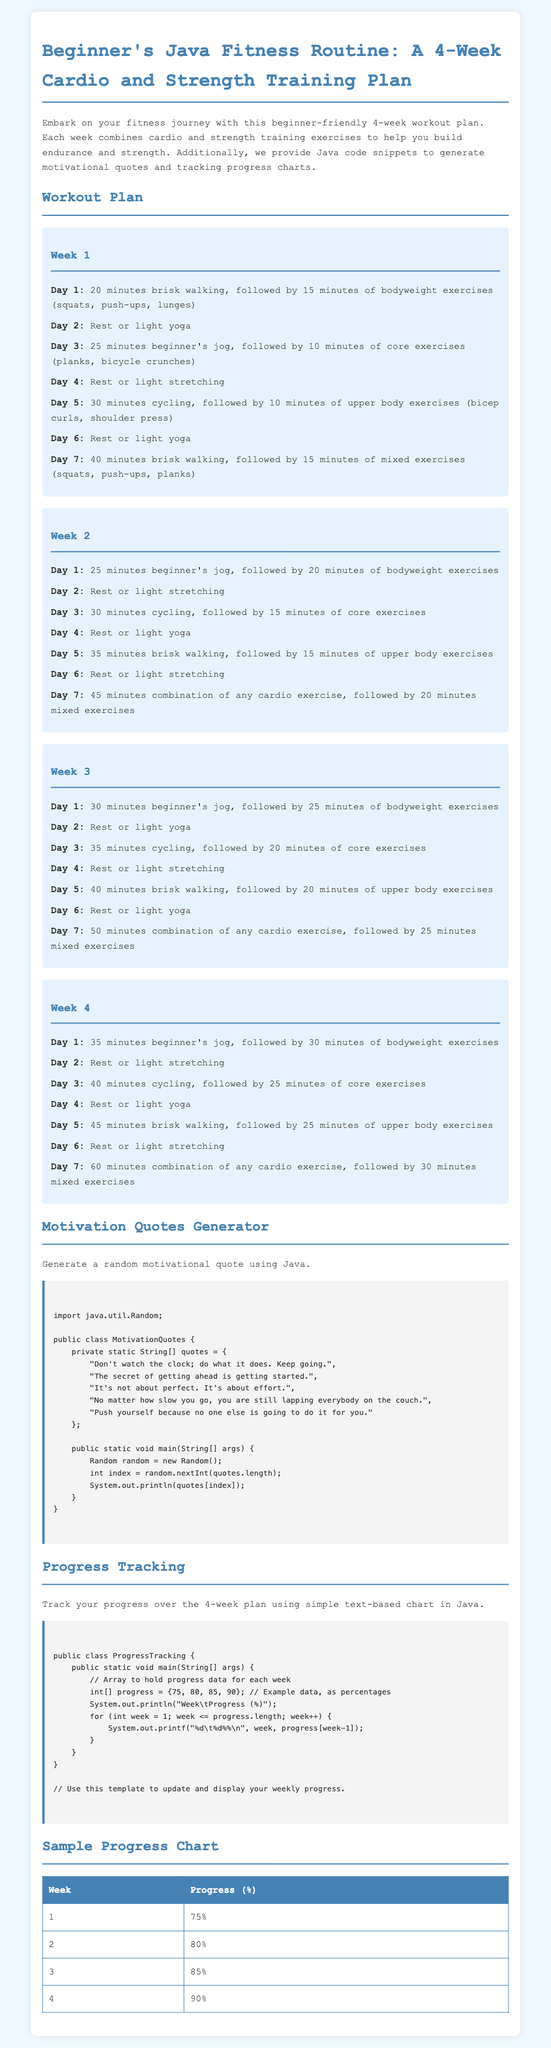What is the duration of Day 1 in Week 1? Day 1 consists of 20 minutes of brisk walking and 15 minutes of bodyweight exercises, making a total of 35 minutes.
Answer: 35 minutes What exercise follows cycling on Day 5 of Week 1? After 30 minutes of cycling, Day 5 includes upper body exercises like bicep curls and shoulder press for 10 minutes.
Answer: Upper body exercises How many total weeks are in the fitness routine? The document outlines a workout plan that spans a total of 4 weeks.
Answer: 4 weeks Which day includes the longest duration of cardio in Week 4? On Day 7 of Week 4, there is a total of 60 minutes of cardio exercise.
Answer: 60 minutes What is the average progress percentage by the end of the plan? The total progress percentages collected over the weeks are 75, 80, 85, and 90, which averages to 82.5.
Answer: 82.5 What is the purpose of the Java code provided in the document? The Java code is designed to generate a random motivational quote and track weekly progress.
Answer: Generate quotes and track progress How many different motivational quotes are included in the Java snippet? The Java code includes a total of 5 motivational quotes.
Answer: 5 quotes What type of chart is used for progress tracking in the workout plan? A simple text-based chart displays weekly progress as percentages.
Answer: Text-based chart 